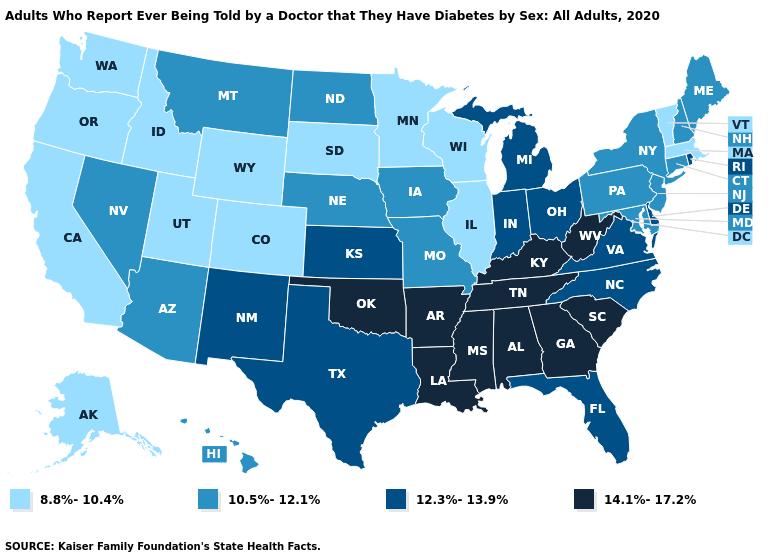Name the states that have a value in the range 14.1%-17.2%?
Answer briefly. Alabama, Arkansas, Georgia, Kentucky, Louisiana, Mississippi, Oklahoma, South Carolina, Tennessee, West Virginia. How many symbols are there in the legend?
Answer briefly. 4. Name the states that have a value in the range 8.8%-10.4%?
Write a very short answer. Alaska, California, Colorado, Idaho, Illinois, Massachusetts, Minnesota, Oregon, South Dakota, Utah, Vermont, Washington, Wisconsin, Wyoming. What is the value of Oregon?
Short answer required. 8.8%-10.4%. Name the states that have a value in the range 14.1%-17.2%?
Keep it brief. Alabama, Arkansas, Georgia, Kentucky, Louisiana, Mississippi, Oklahoma, South Carolina, Tennessee, West Virginia. What is the lowest value in the USA?
Keep it brief. 8.8%-10.4%. Among the states that border Virginia , which have the lowest value?
Be succinct. Maryland. Name the states that have a value in the range 12.3%-13.9%?
Quick response, please. Delaware, Florida, Indiana, Kansas, Michigan, New Mexico, North Carolina, Ohio, Rhode Island, Texas, Virginia. Name the states that have a value in the range 12.3%-13.9%?
Keep it brief. Delaware, Florida, Indiana, Kansas, Michigan, New Mexico, North Carolina, Ohio, Rhode Island, Texas, Virginia. Which states have the lowest value in the MidWest?
Keep it brief. Illinois, Minnesota, South Dakota, Wisconsin. What is the highest value in the USA?
Be succinct. 14.1%-17.2%. What is the value of Connecticut?
Give a very brief answer. 10.5%-12.1%. What is the value of North Dakota?
Be succinct. 10.5%-12.1%. Does Nebraska have a lower value than South Carolina?
Answer briefly. Yes. Name the states that have a value in the range 14.1%-17.2%?
Quick response, please. Alabama, Arkansas, Georgia, Kentucky, Louisiana, Mississippi, Oklahoma, South Carolina, Tennessee, West Virginia. 